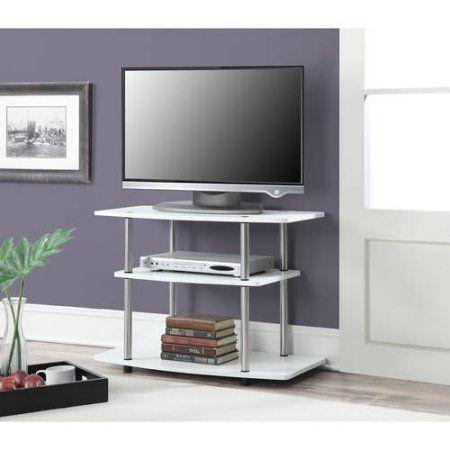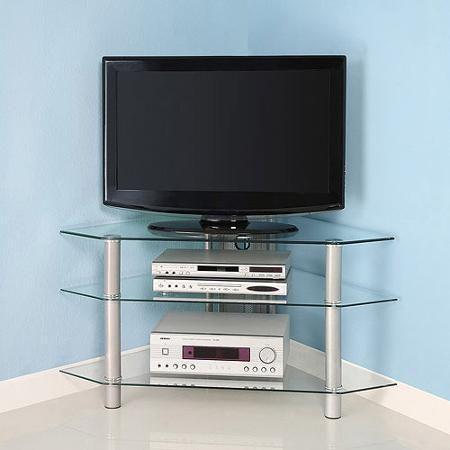The first image is the image on the left, the second image is the image on the right. For the images shown, is this caption "There are more screens in the left image than in the right image." true? Answer yes or no. No. The first image is the image on the left, the second image is the image on the right. Given the left and right images, does the statement "There are multiple monitors in one image, and a TV on a stand in the other image." hold true? Answer yes or no. No. 